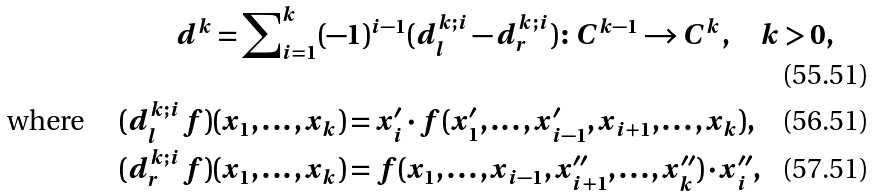Convert formula to latex. <formula><loc_0><loc_0><loc_500><loc_500>d ^ { k } & = \sum \nolimits _ { i = 1 } ^ { k } ( - 1 ) ^ { i - 1 } ( d ^ { k ; i } _ { l } - d ^ { k ; i } _ { r } ) \colon C ^ { k - 1 } \to C ^ { k } , \quad k > 0 , \\ \text {where } \quad ( d ^ { k ; i } _ { l } f ) & ( x _ { 1 } , \dots , x _ { k } ) = x ^ { \prime } _ { i } \cdot f ( x ^ { \prime } _ { 1 } , \dots , x ^ { \prime } _ { i - 1 } , x _ { i + 1 } , \dots , x _ { k } ) , \\ ( d ^ { k ; i } _ { r } f ) & ( x _ { 1 } , \dots , x _ { k } ) = f ( x _ { 1 } , \dots , x _ { i - 1 } , x ^ { \prime \prime } _ { i + 1 } , \dots , x ^ { \prime \prime } _ { k } ) \cdot x ^ { \prime \prime } _ { i } ,</formula> 